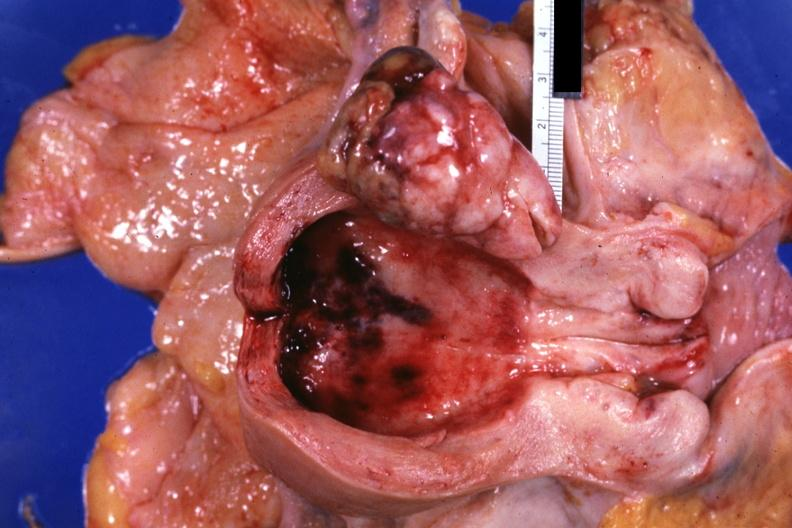what does this image show?
Answer the question using a single word or phrase. Opened uterus polypoid tumor demonstrated 